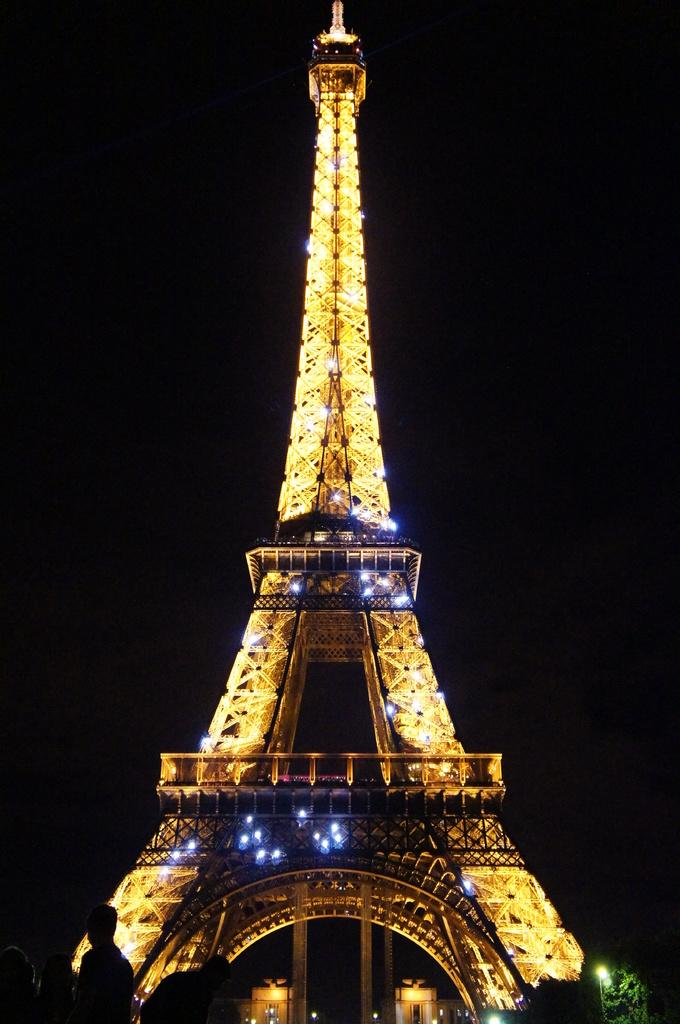What is the main structure in the image? There is a tower in the image. What can be seen on the tower? There are lights on the tower. Where are the people located in the image? The people are standing on the left side of the image. What type of vase can be seen on the tower in the image? There is no vase present on the tower in the image. Are there any toys visible in the image? There is no mention of toys in the provided facts, so we cannot determine if any are present in the image. 